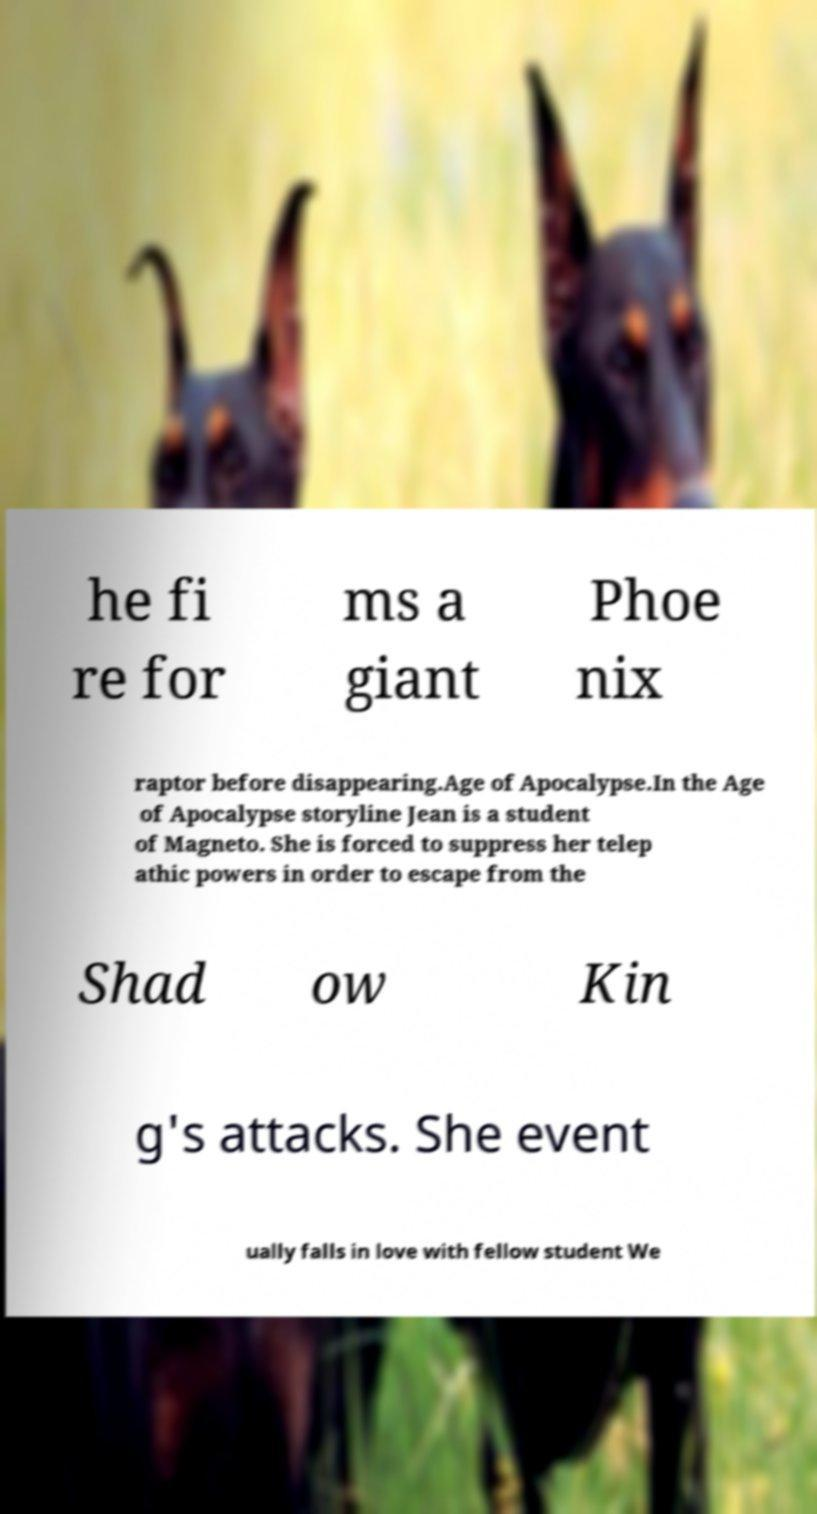Could you extract and type out the text from this image? he fi re for ms a giant Phoe nix raptor before disappearing.Age of Apocalypse.In the Age of Apocalypse storyline Jean is a student of Magneto. She is forced to suppress her telep athic powers in order to escape from the Shad ow Kin g's attacks. She event ually falls in love with fellow student We 